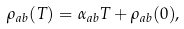<formula> <loc_0><loc_0><loc_500><loc_500>\rho _ { a b } ( T ) = \alpha _ { a b } T + \rho _ { a b } ( 0 ) ,</formula> 